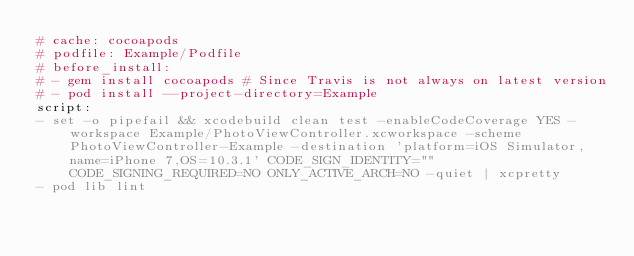Convert code to text. <code><loc_0><loc_0><loc_500><loc_500><_YAML_># cache: cocoapods
# podfile: Example/Podfile
# before_install:
# - gem install cocoapods # Since Travis is not always on latest version
# - pod install --project-directory=Example
script:
- set -o pipefail && xcodebuild clean test -enableCodeCoverage YES -workspace Example/PhotoViewController.xcworkspace -scheme PhotoViewController-Example -destination 'platform=iOS Simulator,name=iPhone 7,OS=10.3.1' CODE_SIGN_IDENTITY="" CODE_SIGNING_REQUIRED=NO ONLY_ACTIVE_ARCH=NO -quiet | xcpretty
- pod lib lint

</code> 